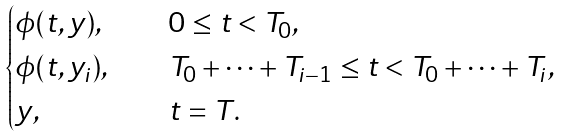<formula> <loc_0><loc_0><loc_500><loc_500>\begin{cases} \phi ( t , y ) , & \quad 0 \leq t < T _ { 0 } , \\ \phi ( t , y _ { i } ) , & \quad T _ { 0 } + \dots + T _ { i - 1 } \leq t < T _ { 0 } + \dots + T _ { i } , \\ y , & \quad t = T . \end{cases}</formula> 